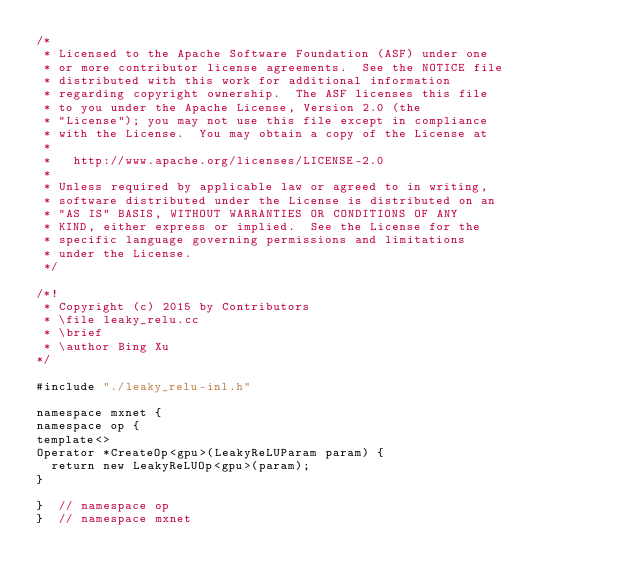Convert code to text. <code><loc_0><loc_0><loc_500><loc_500><_Cuda_>/*
 * Licensed to the Apache Software Foundation (ASF) under one
 * or more contributor license agreements.  See the NOTICE file
 * distributed with this work for additional information
 * regarding copyright ownership.  The ASF licenses this file
 * to you under the Apache License, Version 2.0 (the
 * "License"); you may not use this file except in compliance
 * with the License.  You may obtain a copy of the License at
 *
 *   http://www.apache.org/licenses/LICENSE-2.0
 *
 * Unless required by applicable law or agreed to in writing,
 * software distributed under the License is distributed on an
 * "AS IS" BASIS, WITHOUT WARRANTIES OR CONDITIONS OF ANY
 * KIND, either express or implied.  See the License for the
 * specific language governing permissions and limitations
 * under the License.
 */

/*!
 * Copyright (c) 2015 by Contributors
 * \file leaky_relu.cc
 * \brief
 * \author Bing Xu
*/

#include "./leaky_relu-inl.h"

namespace mxnet {
namespace op {
template<>
Operator *CreateOp<gpu>(LeakyReLUParam param) {
  return new LeakyReLUOp<gpu>(param);
}

}  // namespace op
}  // namespace mxnet

</code> 